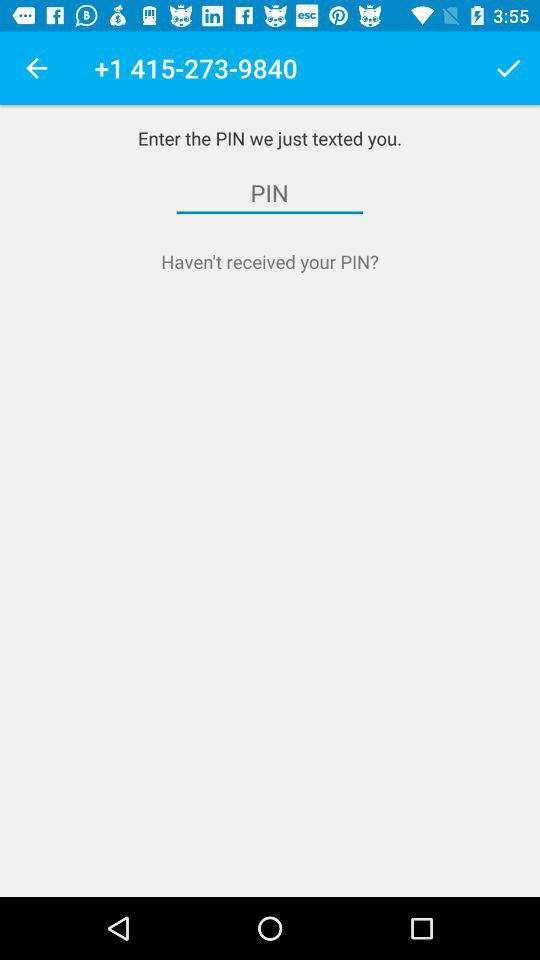What is the given phone number? The given phone number is +1 415-273-9840. 